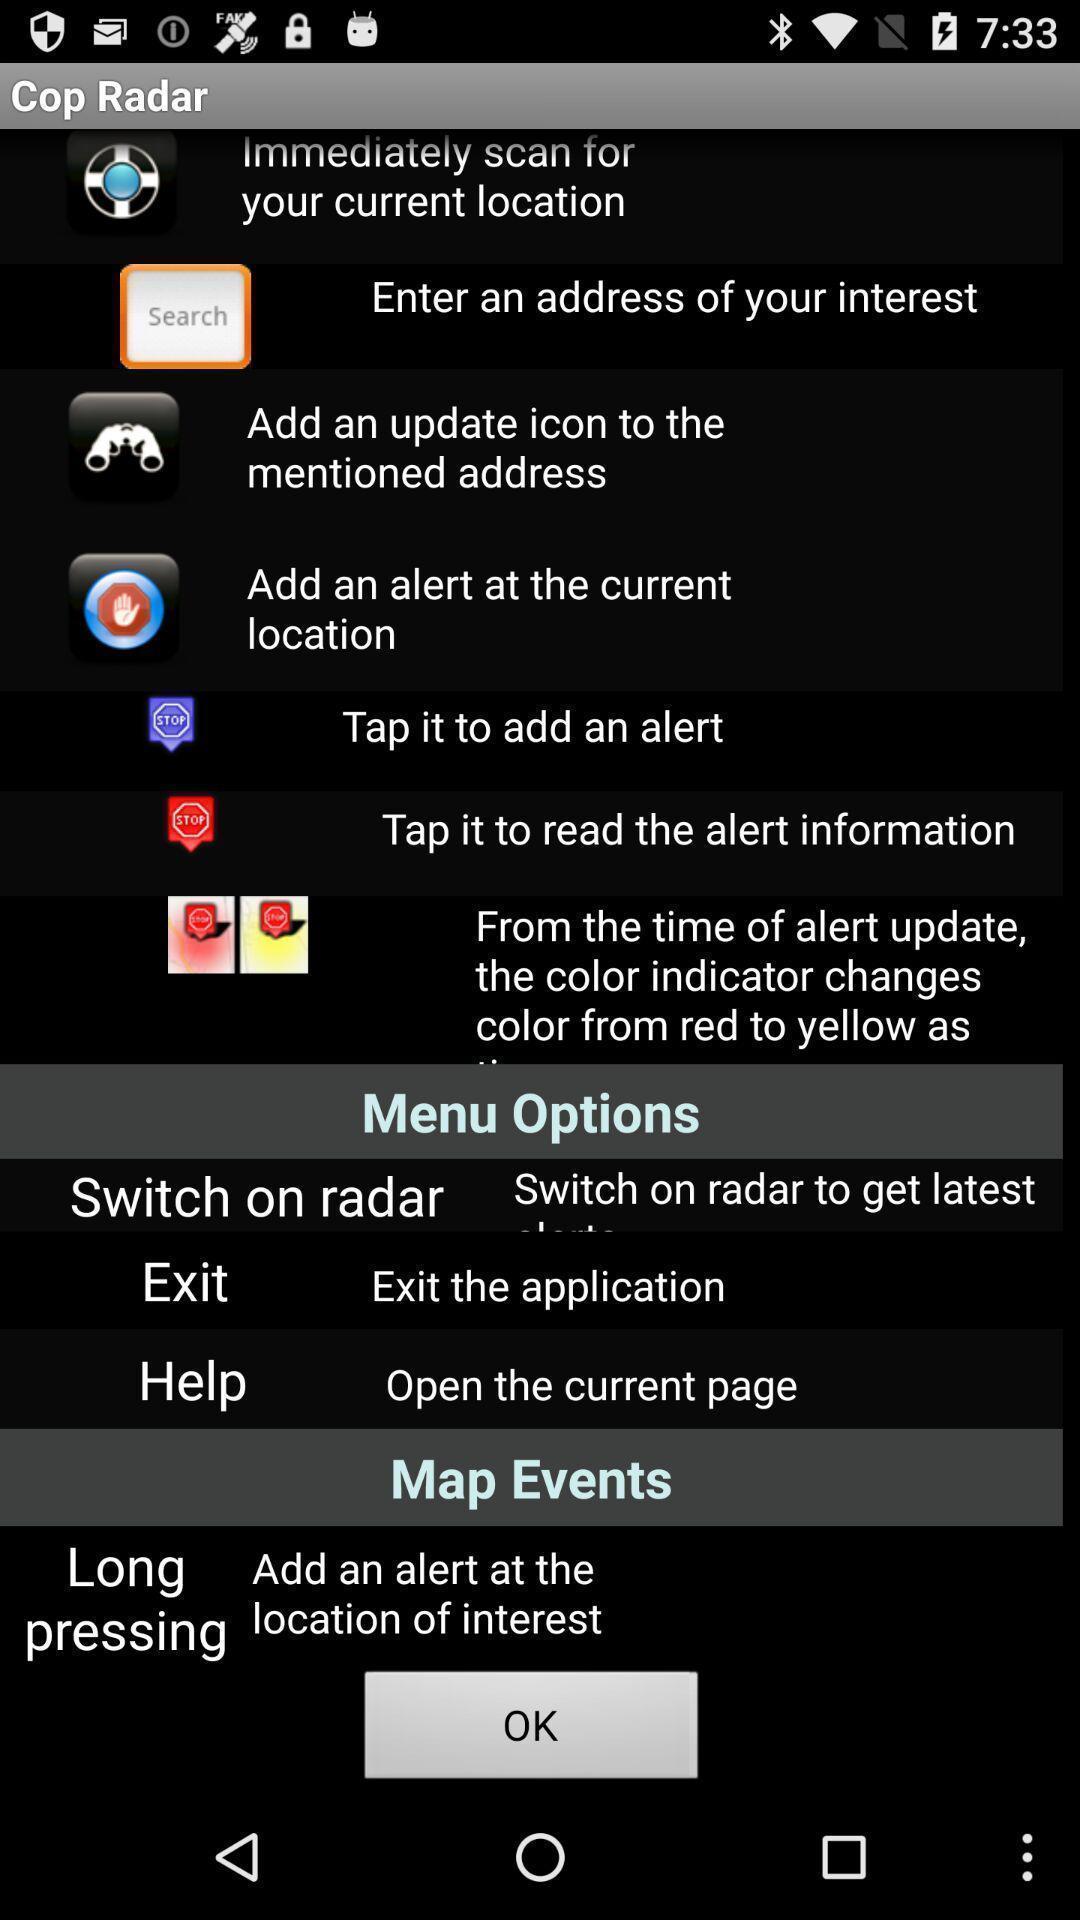Describe the content in this image. Various options in the application. 